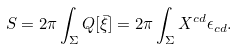Convert formula to latex. <formula><loc_0><loc_0><loc_500><loc_500>S = 2 \pi \int _ { \Sigma } Q [ \bar { \xi } ] = 2 \pi \int _ { \Sigma } X ^ { c d } \epsilon _ { c d } .</formula> 